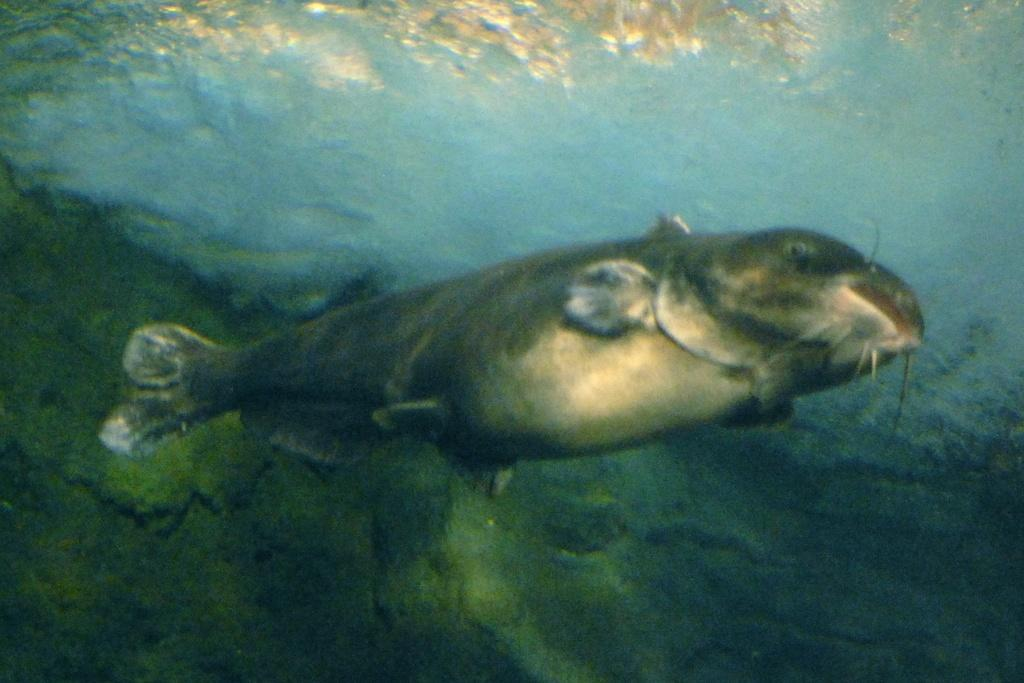What type of animal is in the image? There is a fish in the image. Where is the fish located? The fish is in the water. What type of weather can be seen in the image? There is no weather visible in the image, as it only features a fish in the water. What type of tool is being used by the fish in the image? There are no tools present in the image, as it only features a fish in the water. 